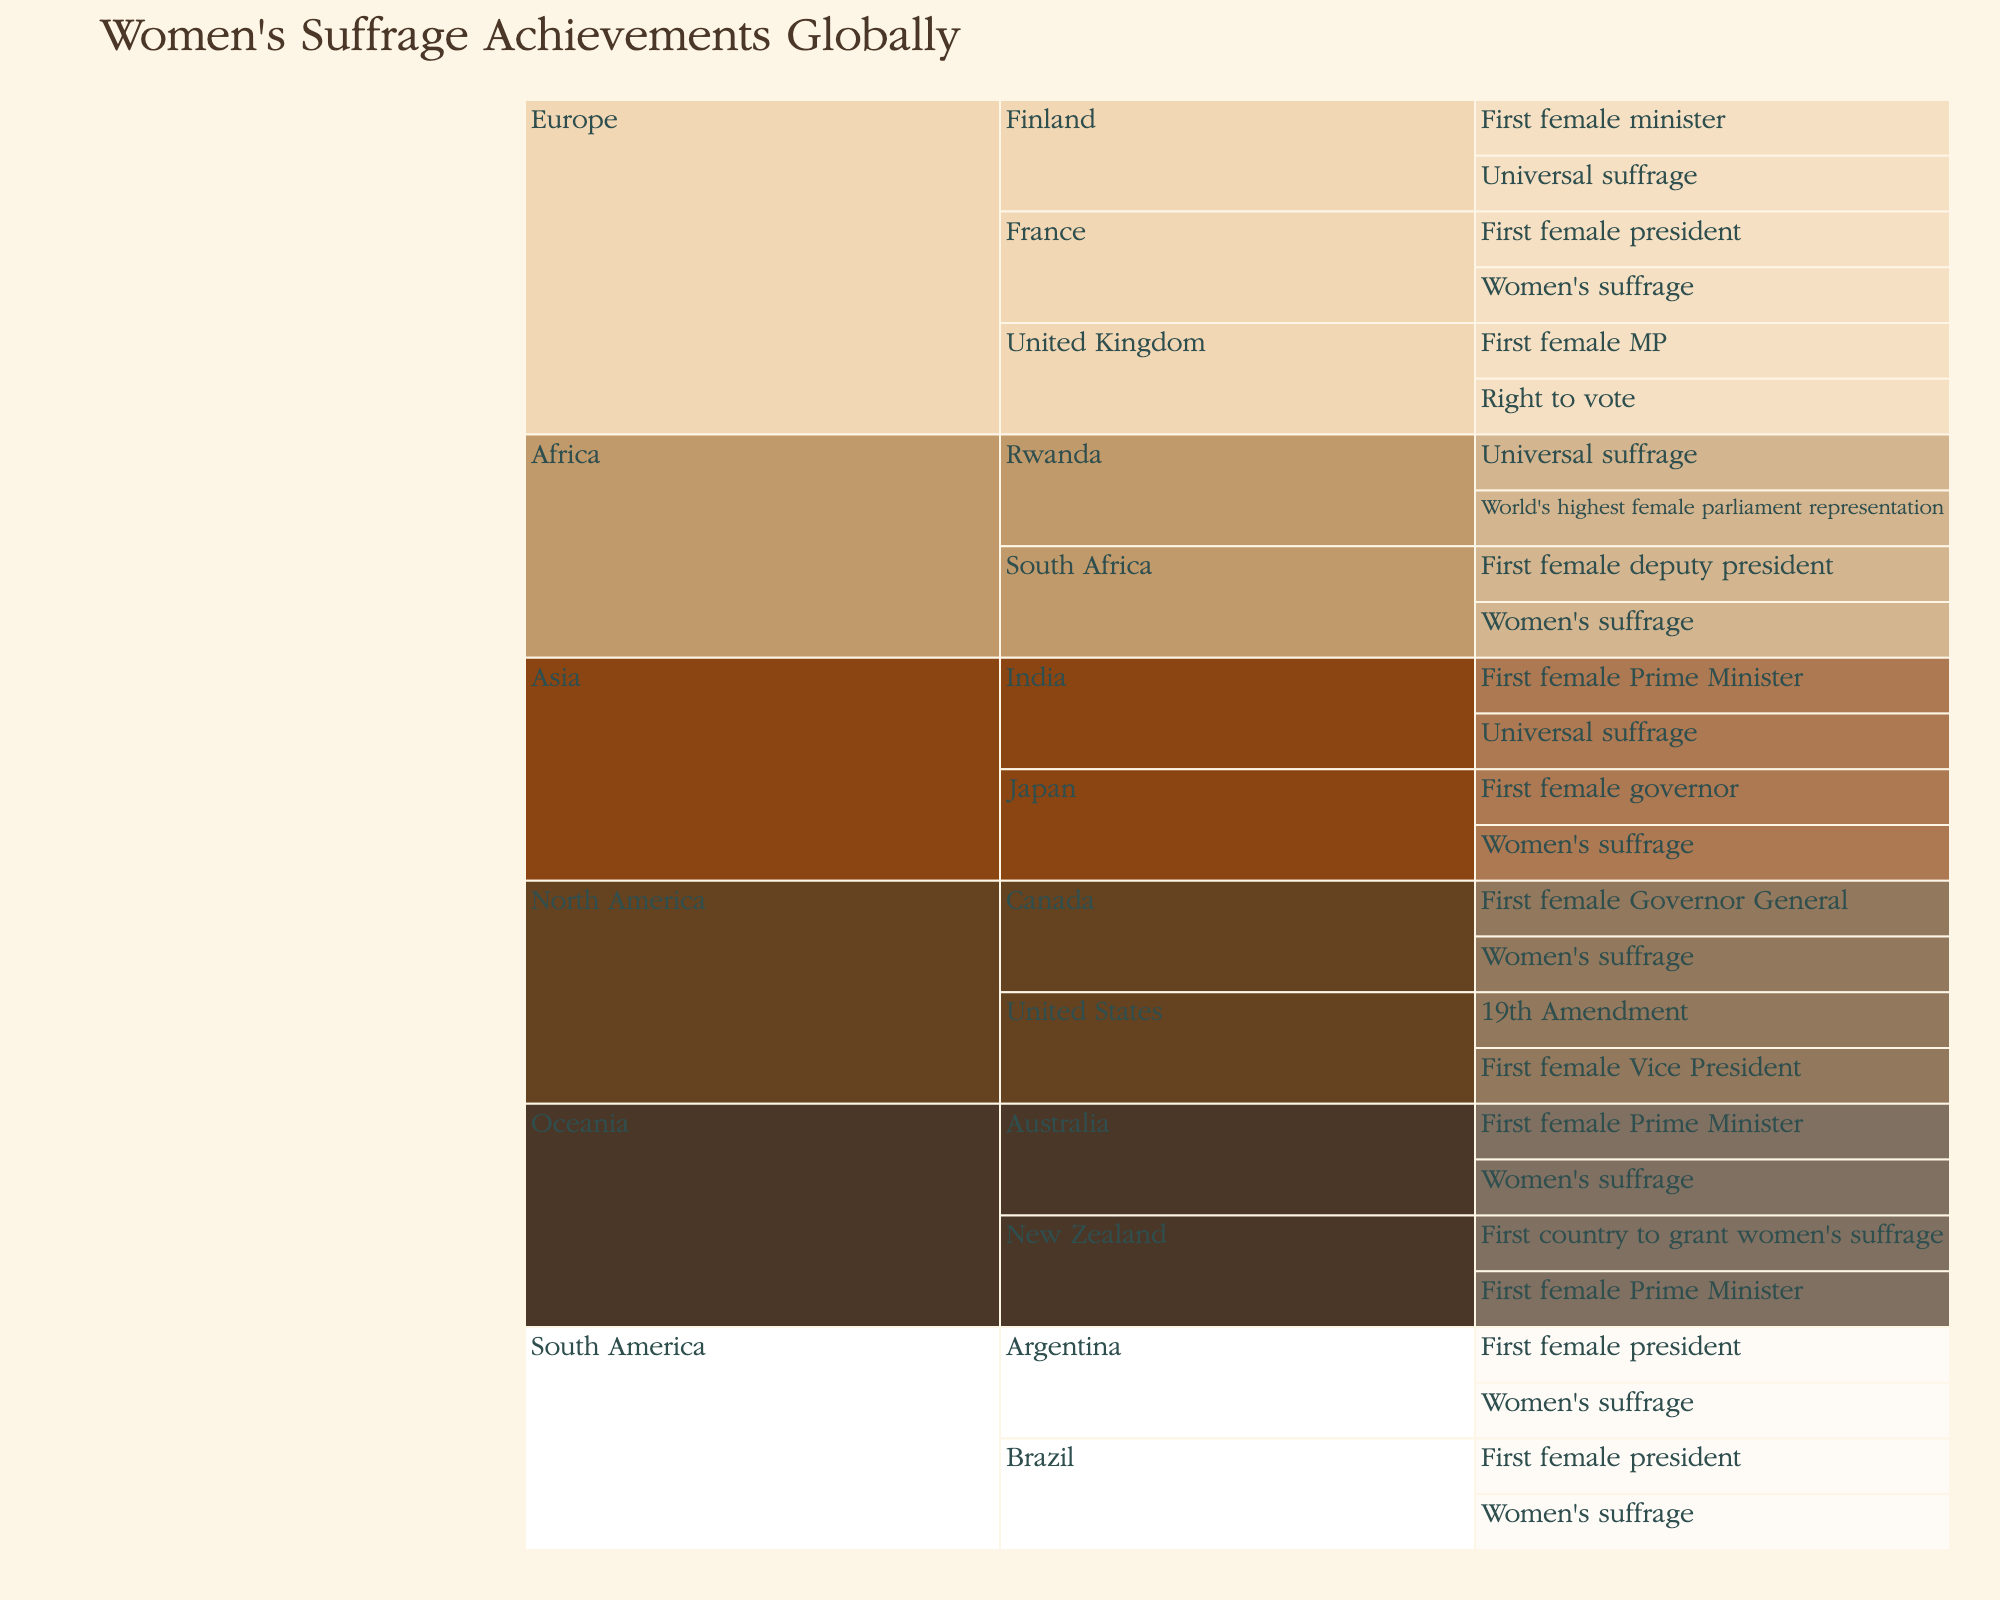What's the title of the figure? The title of the figure is placed at the top and is the main text header of the chart, presented in a larger font size compared to other text elements.
Answer: Women's Suffrage Achievements Globally Which continent has the highest number of women's suffrage achievements listed? By counting the individual achievements under each continent, we can determine that the continent with the highest number of women's suffrage achievements is Europe.
Answer: Europe How many unique achievements are recorded for North America? By examining the subsets within North America, we see that the United States has 2 achievements and Canada has 2, making a total of 4 unique achievements.
Answer: 4 Which country in South America has both women's suffrage and a female president recorded? In the figure, under South America, the countries listed with both women's suffrage and a female president are Brazil and Argentina.
Answer: Brazil and Argentina Which continent first achieved universal suffrage, according to the figure? The figure shows that New Zealand in Oceania was the first country to grant women's suffrage, and Finland in Europe achieved universal suffrage. However, New Zealand's achievement happened earlier in history.
Answer: Oceania What can you infer about the data distribution within Africa regarding women's suffrage achievements? Africa shows achievements for South Africa and Rwanda. South Africa has two achievements, while Rwanda also has two, indicating an approximately equal distribution of key achievements between these countries.
Answer: Equal distribution between South Africa and Rwanda Which country has the distinction of having the world's highest female parliament representation? The specific achievement for world's highest female parliament representation is listed under the continent Africa, for the country Rwanda.
Answer: Rwanda Between Australia and India, which country achieved a female prime minister first? By referencing the achievements listed, Australia in Oceania and India in Asia both have listed 'First female Prime Minister', but the timeline of historical milestones generally viewed places Australia achieving this earlier.
Answer: Australia How many countries are listed from Europe with multiple achievements in the figure? By observing the subset for Europe, we notice the United Kingdom, Finland, and France each have multiple achievements listed. This counts to a total of three countries.
Answer: 3 Which country is noted for being the first to grant women's suffrage? The achievement 'First country to grant women's suffrage' is listed under New Zealand in the continent Oceania.
Answer: New Zealand 